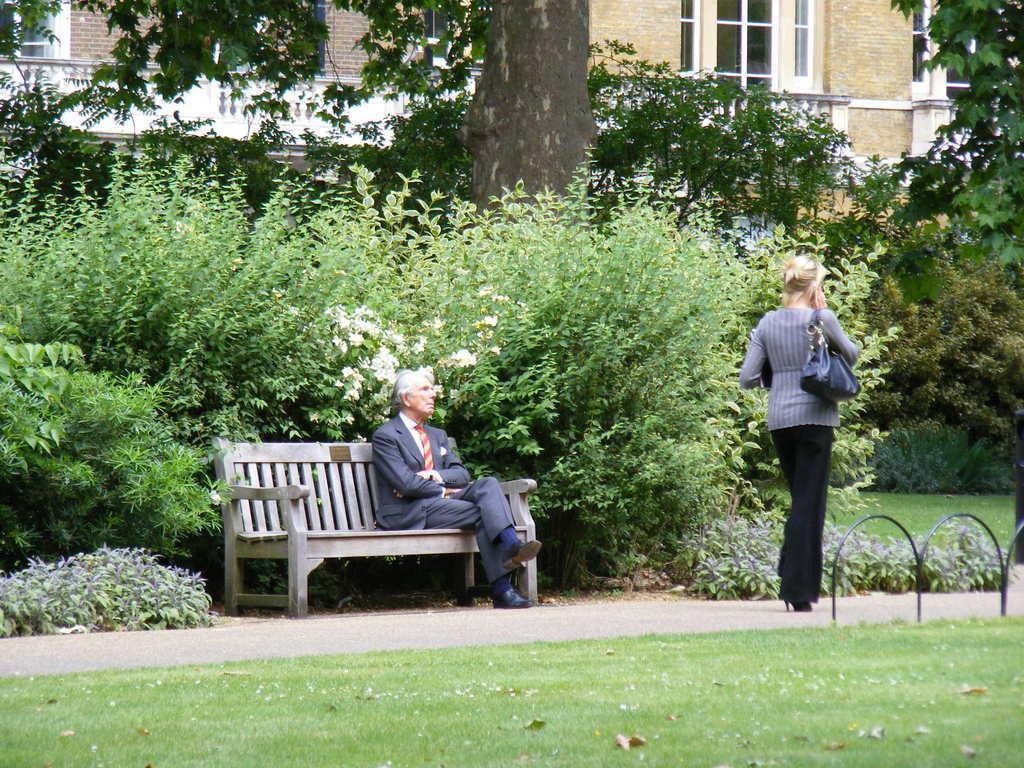In one or two sentences, can you explain what this image depicts? In this image I can see a person is sitting on the bench. The woman is walking on the road. The woman is wearing a handbag. At the back side there are small plants and a trees. There is a building and a windows. The man is wearing the blue blazer and a red tie. The woman is wearing the grey top and a blank pant. 